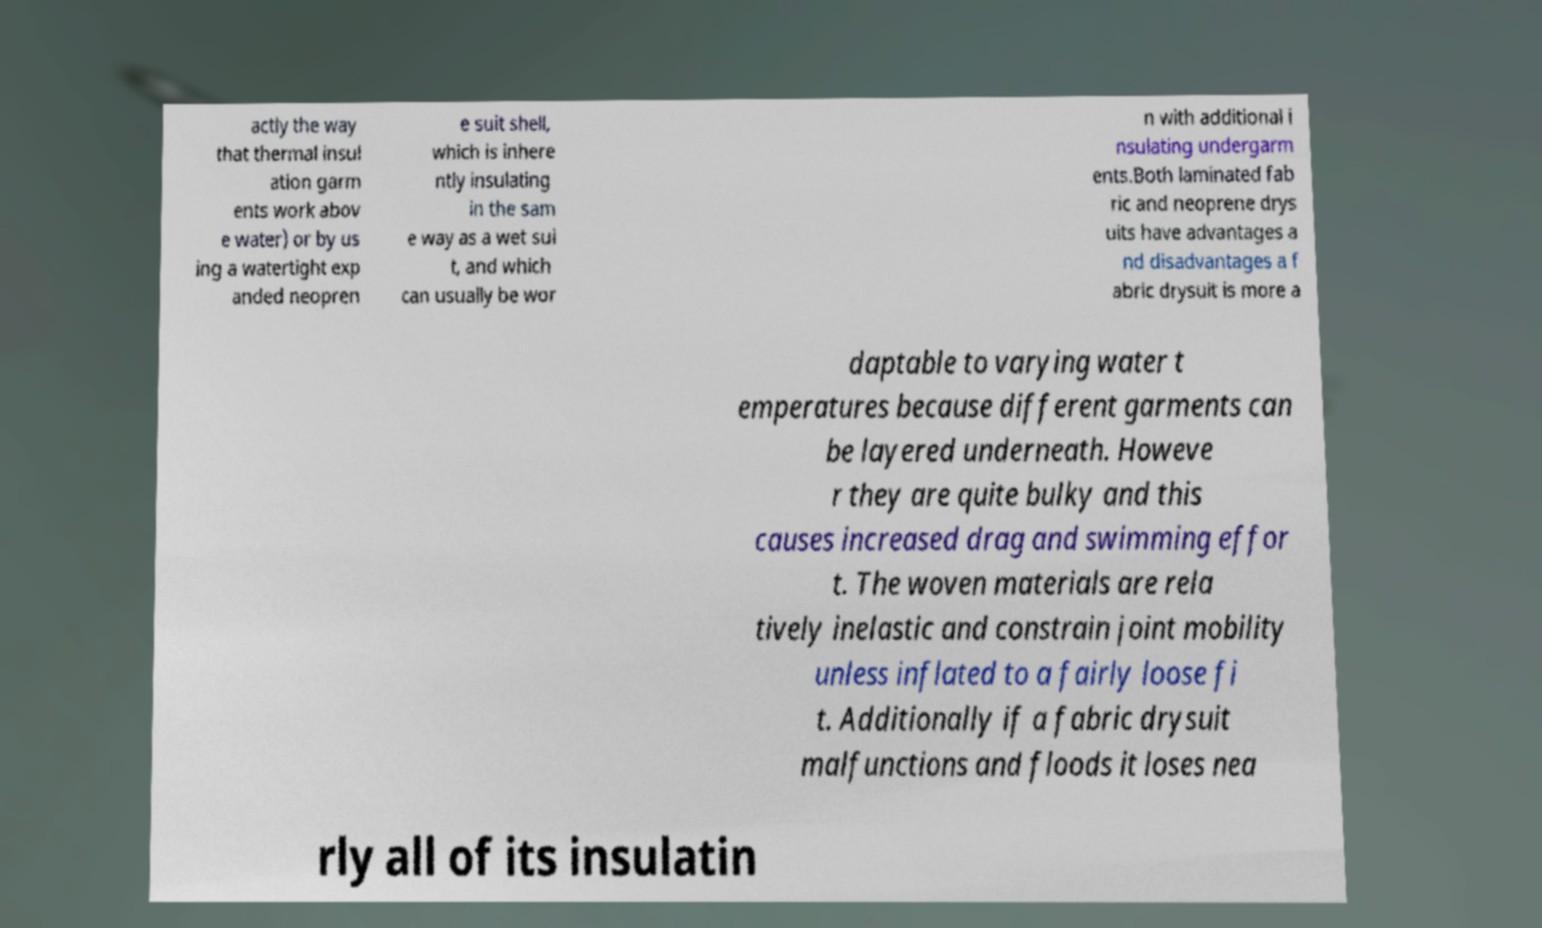There's text embedded in this image that I need extracted. Can you transcribe it verbatim? actly the way that thermal insul ation garm ents work abov e water) or by us ing a watertight exp anded neopren e suit shell, which is inhere ntly insulating in the sam e way as a wet sui t, and which can usually be wor n with additional i nsulating undergarm ents.Both laminated fab ric and neoprene drys uits have advantages a nd disadvantages a f abric drysuit is more a daptable to varying water t emperatures because different garments can be layered underneath. Howeve r they are quite bulky and this causes increased drag and swimming effor t. The woven materials are rela tively inelastic and constrain joint mobility unless inflated to a fairly loose fi t. Additionally if a fabric drysuit malfunctions and floods it loses nea rly all of its insulatin 